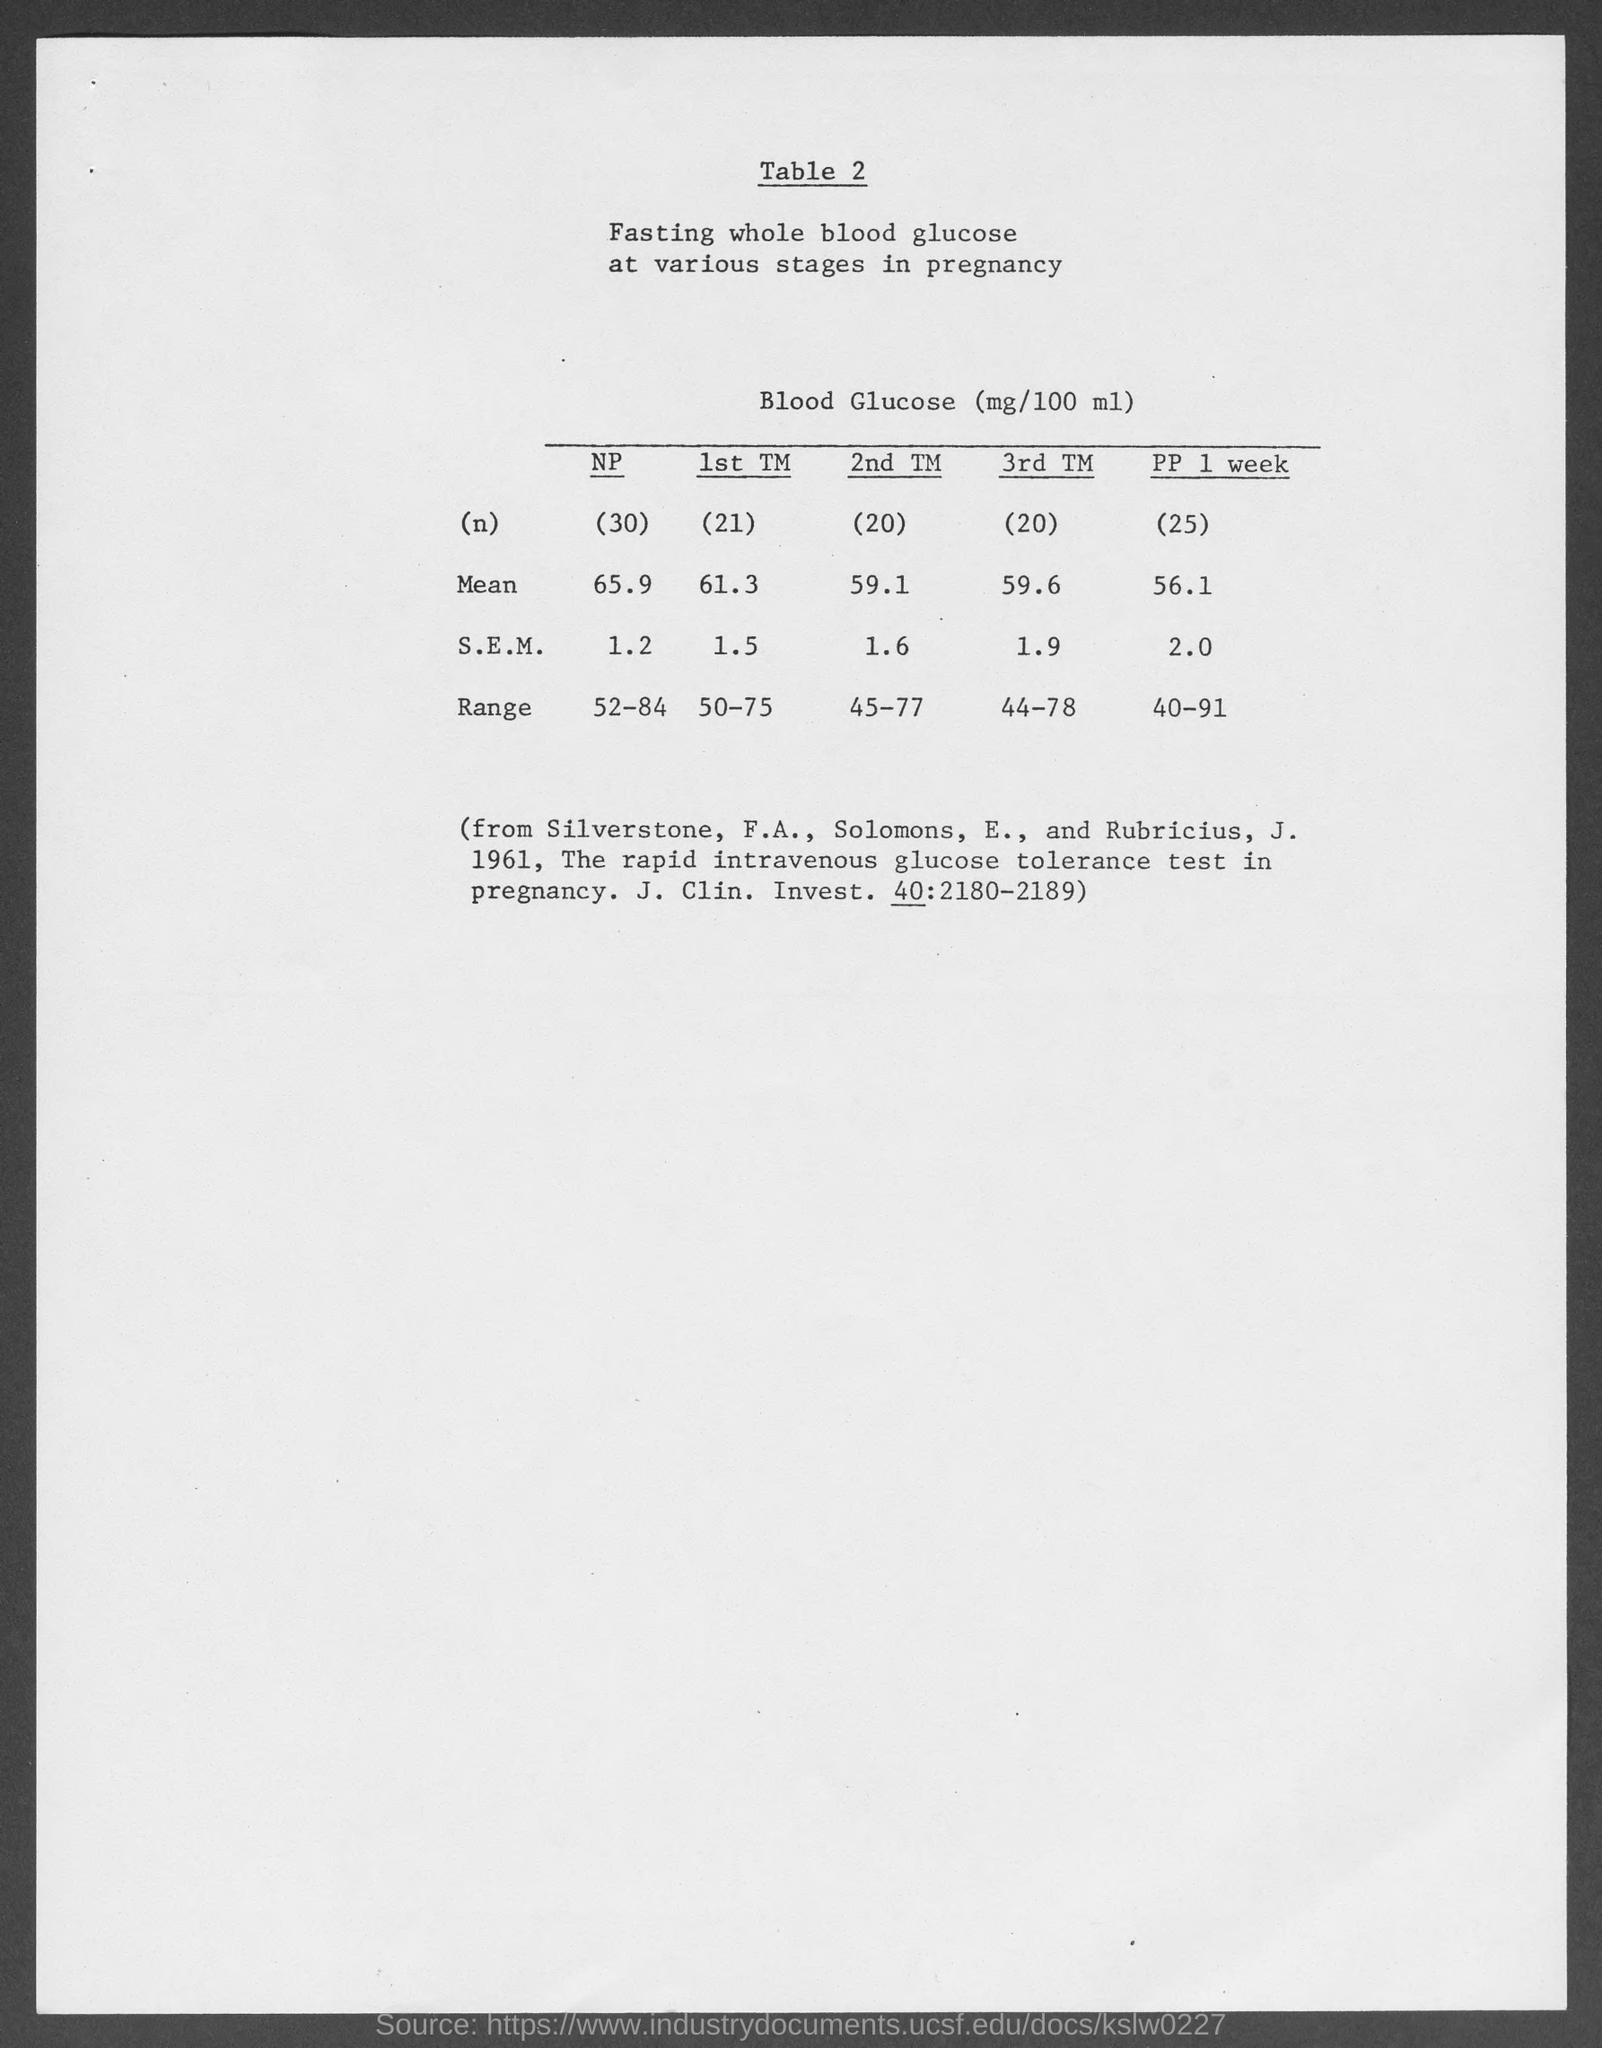How do glucose levels change from the non-pregnant state to one week post-partum according to the table? The table shows a decrease in fasting whole blood glucose levels from the non-pregnant (NP) state, with a mean of 65.9 mg/100 ml, to one week post-partum (PP 1 week), where the mean is 56.1 mg/100 ml. 